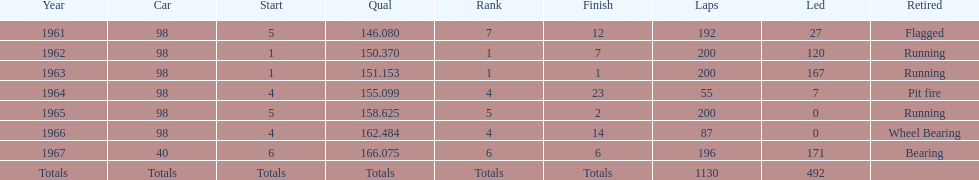Would you be able to parse every entry in this table? {'header': ['Year', 'Car', 'Start', 'Qual', 'Rank', 'Finish', 'Laps', 'Led', 'Retired'], 'rows': [['1961', '98', '5', '146.080', '7', '12', '192', '27', 'Flagged'], ['1962', '98', '1', '150.370', '1', '7', '200', '120', 'Running'], ['1963', '98', '1', '151.153', '1', '1', '200', '167', 'Running'], ['1964', '98', '4', '155.099', '4', '23', '55', '7', 'Pit fire'], ['1965', '98', '5', '158.625', '5', '2', '200', '0', 'Running'], ['1966', '98', '4', '162.484', '4', '14', '87', '0', 'Wheel Bearing'], ['1967', '40', '6', '166.075', '6', '6', '196', '171', 'Bearing'], ['Totals', 'Totals', 'Totals', 'Totals', 'Totals', 'Totals', '1130', '492', '']]} How many overall laps have been raced in the indy 500? 1130. 